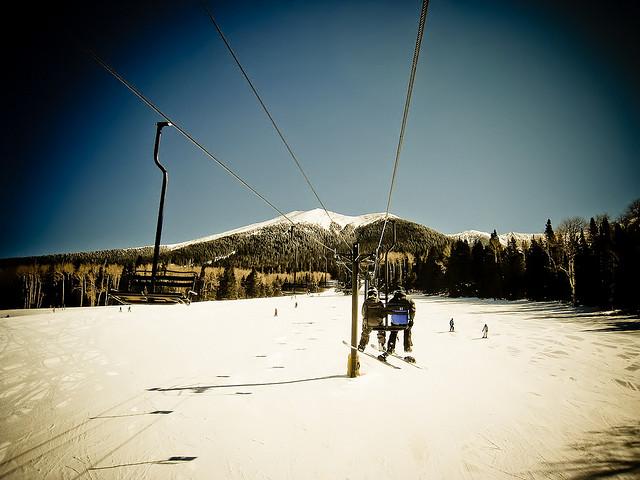Is this a beach resort?
Be succinct. No. Why is the ground white?
Quick response, please. Snow. Is the man skiing down the mountain?
Short answer required. No. What recreation are the people in the air planning to be apart of?
Keep it brief. Skiing. 